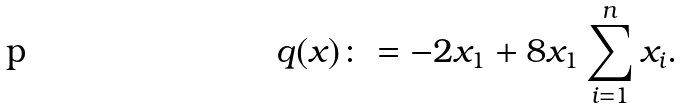Convert formula to latex. <formula><loc_0><loc_0><loc_500><loc_500>q ( x ) \colon = - 2 x _ { 1 } + 8 x _ { 1 } \sum _ { i = 1 } ^ { n } x _ { i } .</formula> 